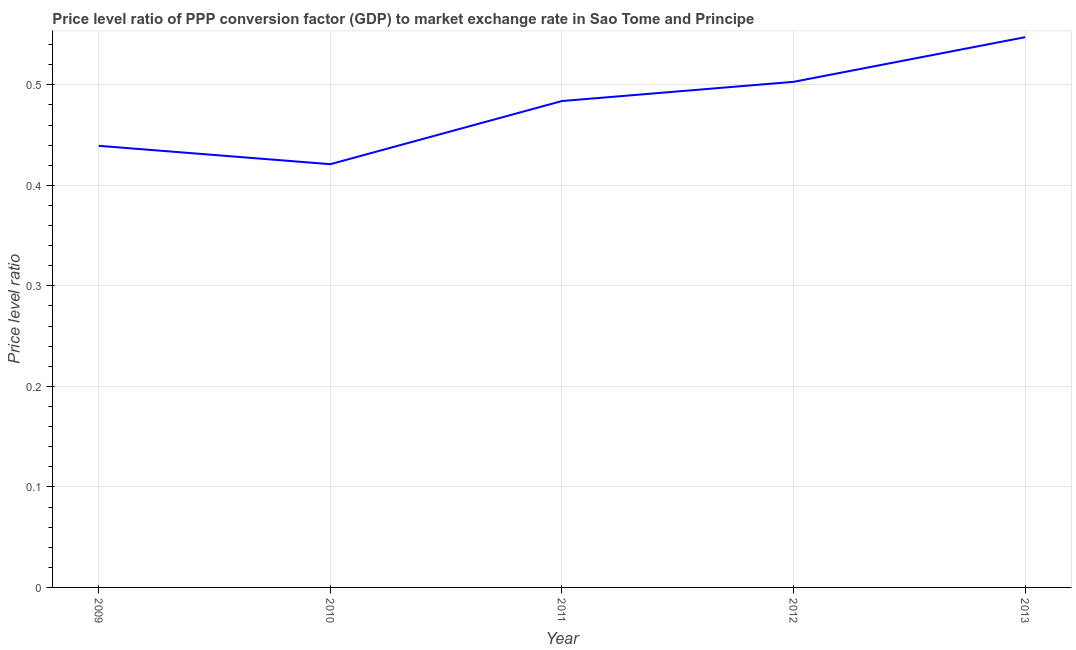What is the price level ratio in 2009?
Offer a terse response. 0.44. Across all years, what is the maximum price level ratio?
Your response must be concise. 0.55. Across all years, what is the minimum price level ratio?
Your answer should be very brief. 0.42. In which year was the price level ratio maximum?
Ensure brevity in your answer.  2013. In which year was the price level ratio minimum?
Ensure brevity in your answer.  2010. What is the sum of the price level ratio?
Provide a short and direct response. 2.39. What is the difference between the price level ratio in 2009 and 2012?
Your response must be concise. -0.06. What is the average price level ratio per year?
Offer a very short reply. 0.48. What is the median price level ratio?
Your answer should be very brief. 0.48. In how many years, is the price level ratio greater than 0.02 ?
Ensure brevity in your answer.  5. Do a majority of the years between 2010 and 2012 (inclusive) have price level ratio greater than 0.14 ?
Make the answer very short. Yes. What is the ratio of the price level ratio in 2009 to that in 2010?
Provide a short and direct response. 1.04. Is the price level ratio in 2009 less than that in 2010?
Ensure brevity in your answer.  No. What is the difference between the highest and the second highest price level ratio?
Keep it short and to the point. 0.04. What is the difference between the highest and the lowest price level ratio?
Make the answer very short. 0.13. In how many years, is the price level ratio greater than the average price level ratio taken over all years?
Give a very brief answer. 3. Does the graph contain grids?
Offer a terse response. Yes. What is the title of the graph?
Provide a short and direct response. Price level ratio of PPP conversion factor (GDP) to market exchange rate in Sao Tome and Principe. What is the label or title of the X-axis?
Provide a short and direct response. Year. What is the label or title of the Y-axis?
Keep it short and to the point. Price level ratio. What is the Price level ratio in 2009?
Ensure brevity in your answer.  0.44. What is the Price level ratio in 2010?
Keep it short and to the point. 0.42. What is the Price level ratio of 2011?
Ensure brevity in your answer.  0.48. What is the Price level ratio in 2012?
Your answer should be compact. 0.5. What is the Price level ratio of 2013?
Ensure brevity in your answer.  0.55. What is the difference between the Price level ratio in 2009 and 2010?
Provide a short and direct response. 0.02. What is the difference between the Price level ratio in 2009 and 2011?
Ensure brevity in your answer.  -0.04. What is the difference between the Price level ratio in 2009 and 2012?
Provide a succinct answer. -0.06. What is the difference between the Price level ratio in 2009 and 2013?
Keep it short and to the point. -0.11. What is the difference between the Price level ratio in 2010 and 2011?
Ensure brevity in your answer.  -0.06. What is the difference between the Price level ratio in 2010 and 2012?
Provide a succinct answer. -0.08. What is the difference between the Price level ratio in 2010 and 2013?
Your answer should be very brief. -0.13. What is the difference between the Price level ratio in 2011 and 2012?
Offer a terse response. -0.02. What is the difference between the Price level ratio in 2011 and 2013?
Your answer should be very brief. -0.06. What is the difference between the Price level ratio in 2012 and 2013?
Make the answer very short. -0.04. What is the ratio of the Price level ratio in 2009 to that in 2010?
Give a very brief answer. 1.04. What is the ratio of the Price level ratio in 2009 to that in 2011?
Give a very brief answer. 0.91. What is the ratio of the Price level ratio in 2009 to that in 2012?
Keep it short and to the point. 0.87. What is the ratio of the Price level ratio in 2009 to that in 2013?
Give a very brief answer. 0.8. What is the ratio of the Price level ratio in 2010 to that in 2011?
Provide a succinct answer. 0.87. What is the ratio of the Price level ratio in 2010 to that in 2012?
Your answer should be compact. 0.84. What is the ratio of the Price level ratio in 2010 to that in 2013?
Offer a terse response. 0.77. What is the ratio of the Price level ratio in 2011 to that in 2013?
Offer a terse response. 0.88. What is the ratio of the Price level ratio in 2012 to that in 2013?
Provide a short and direct response. 0.92. 